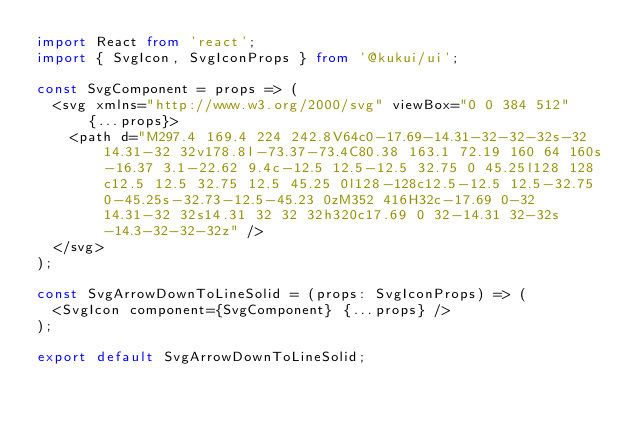<code> <loc_0><loc_0><loc_500><loc_500><_TypeScript_>import React from 'react';
import { SvgIcon, SvgIconProps } from '@kukui/ui';

const SvgComponent = props => (
  <svg xmlns="http://www.w3.org/2000/svg" viewBox="0 0 384 512" {...props}>
    <path d="M297.4 169.4 224 242.8V64c0-17.69-14.31-32-32-32s-32 14.31-32 32v178.8l-73.37-73.4C80.38 163.1 72.19 160 64 160s-16.37 3.1-22.62 9.4c-12.5 12.5-12.5 32.75 0 45.25l128 128c12.5 12.5 32.75 12.5 45.25 0l128-128c12.5-12.5 12.5-32.75 0-45.25s-32.73-12.5-45.23 0zM352 416H32c-17.69 0-32 14.31-32 32s14.31 32 32 32h320c17.69 0 32-14.31 32-32s-14.3-32-32-32z" />
  </svg>
);

const SvgArrowDownToLineSolid = (props: SvgIconProps) => (
  <SvgIcon component={SvgComponent} {...props} />
);

export default SvgArrowDownToLineSolid;
</code> 